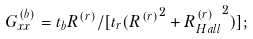<formula> <loc_0><loc_0><loc_500><loc_500>G _ { x x } ^ { ( b ) } = t _ { b } R ^ { ( r ) } / [ t _ { r } ( { R ^ { ( r ) } } ^ { 2 } + { R _ { H a l l } ^ { ( r ) } } ^ { 2 } ) ] ;</formula> 